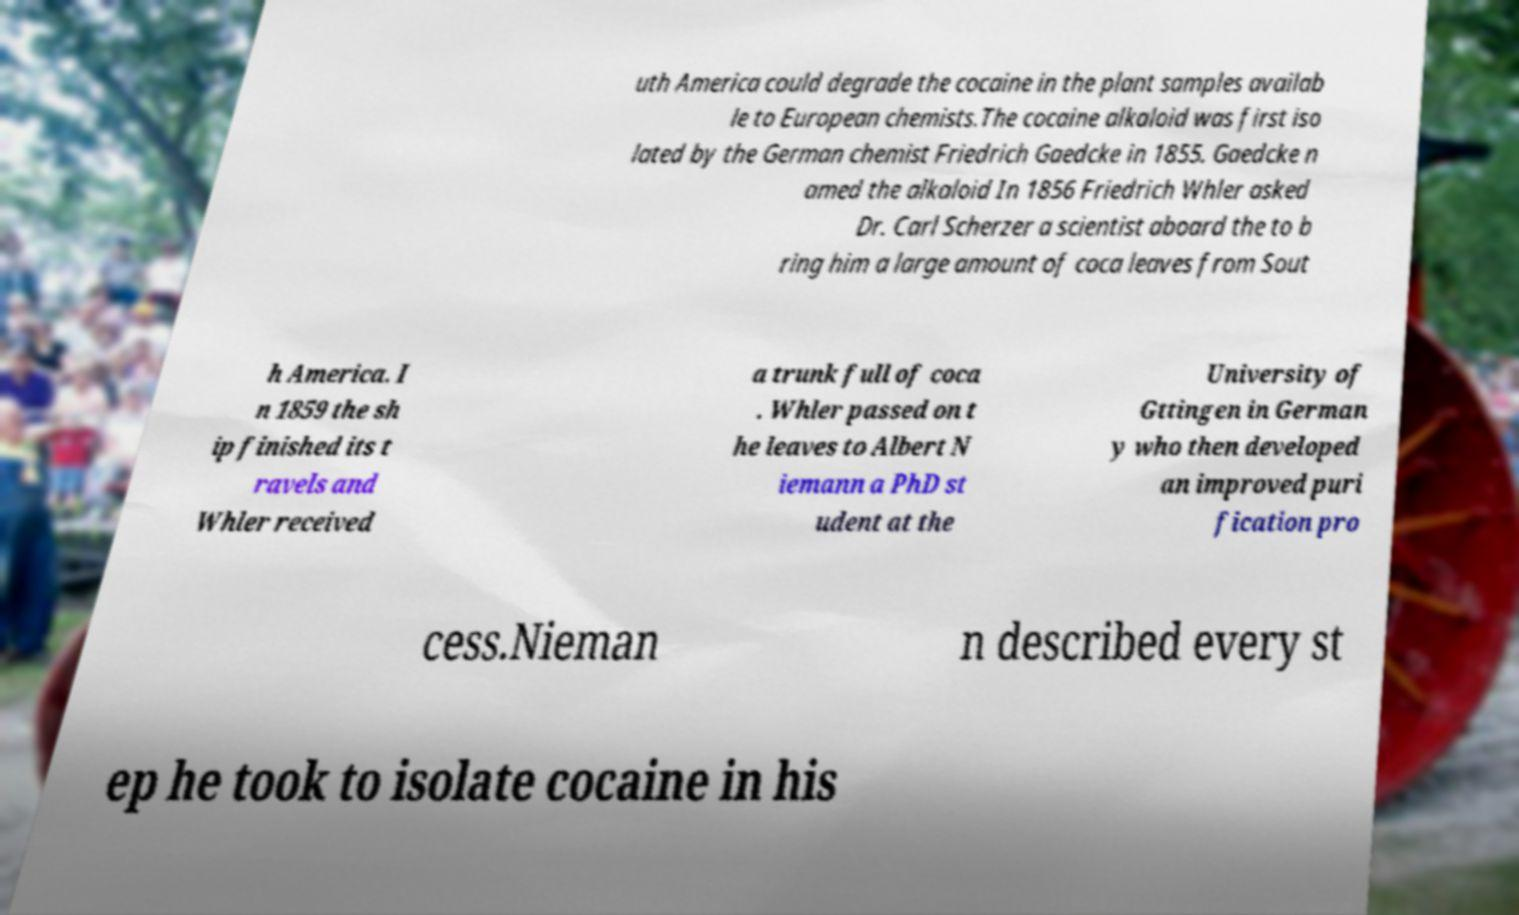Can you accurately transcribe the text from the provided image for me? uth America could degrade the cocaine in the plant samples availab le to European chemists.The cocaine alkaloid was first iso lated by the German chemist Friedrich Gaedcke in 1855. Gaedcke n amed the alkaloid In 1856 Friedrich Whler asked Dr. Carl Scherzer a scientist aboard the to b ring him a large amount of coca leaves from Sout h America. I n 1859 the sh ip finished its t ravels and Whler received a trunk full of coca . Whler passed on t he leaves to Albert N iemann a PhD st udent at the University of Gttingen in German y who then developed an improved puri fication pro cess.Nieman n described every st ep he took to isolate cocaine in his 